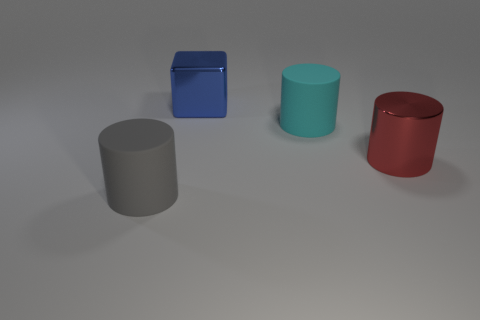Add 4 large cyan rubber things. How many objects exist? 8 Subtract all cylinders. How many objects are left? 1 Add 1 gray things. How many gray things exist? 2 Subtract 1 red cylinders. How many objects are left? 3 Subtract all green shiny cylinders. Subtract all large blue blocks. How many objects are left? 3 Add 1 big metallic cylinders. How many big metallic cylinders are left? 2 